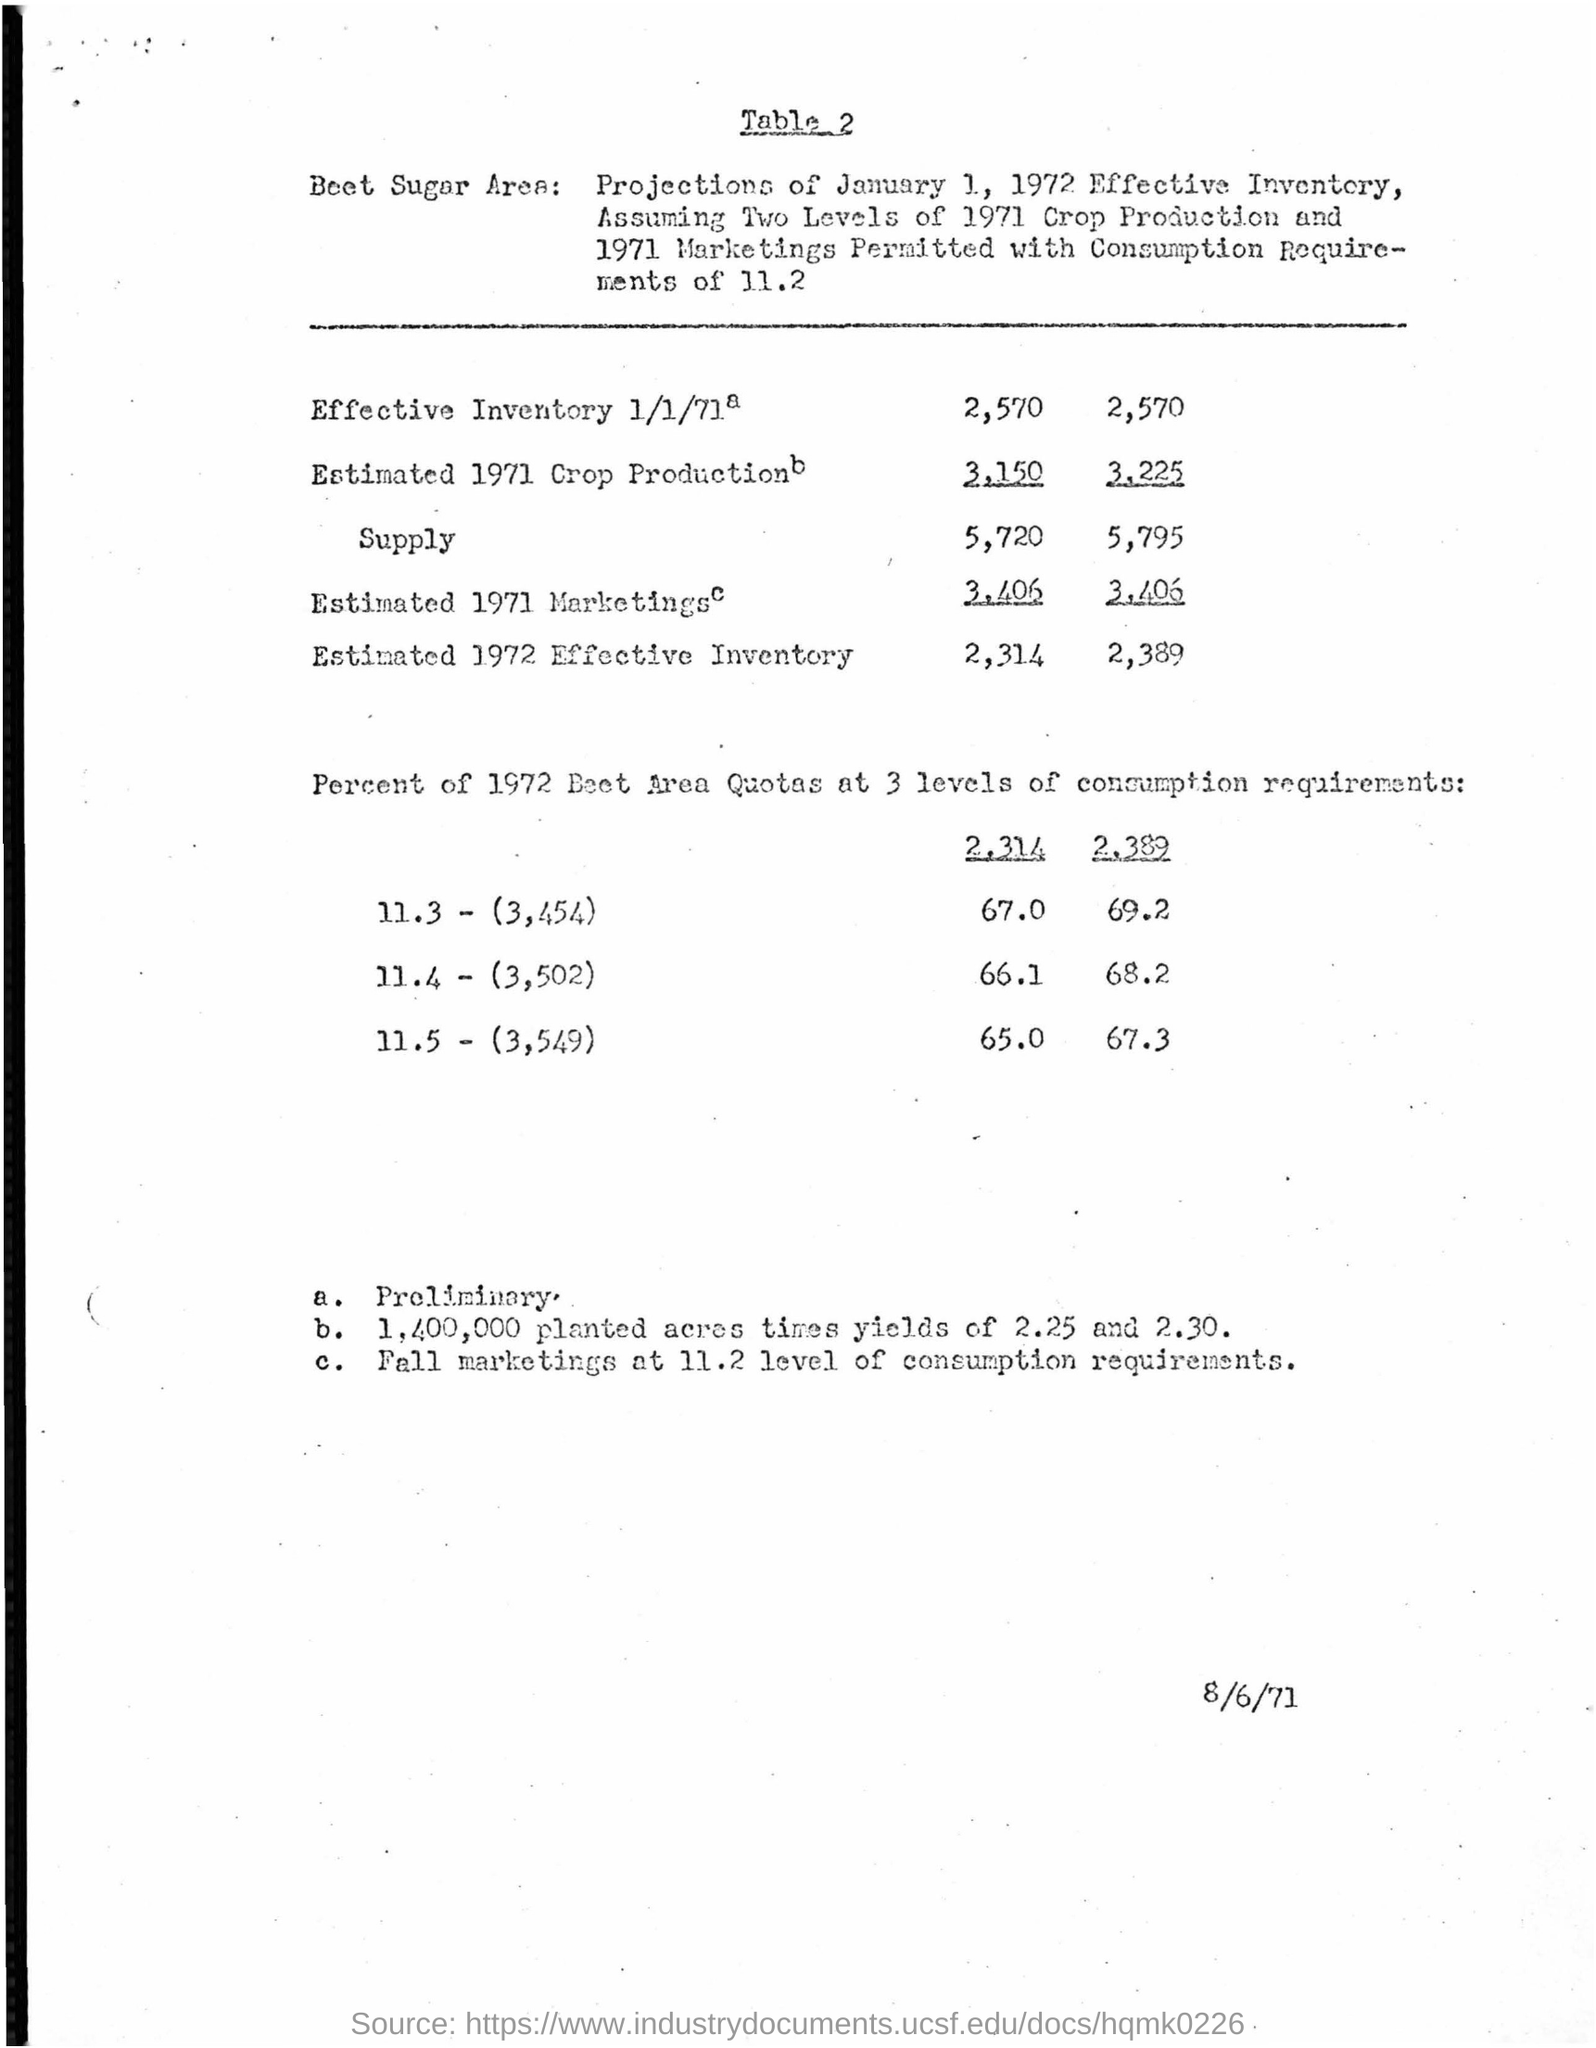What is the main heading of document ?
Keep it short and to the point. Table 2. What is the date mentioned in the bottom of the document ?
Provide a short and direct response. 8/6/71. 